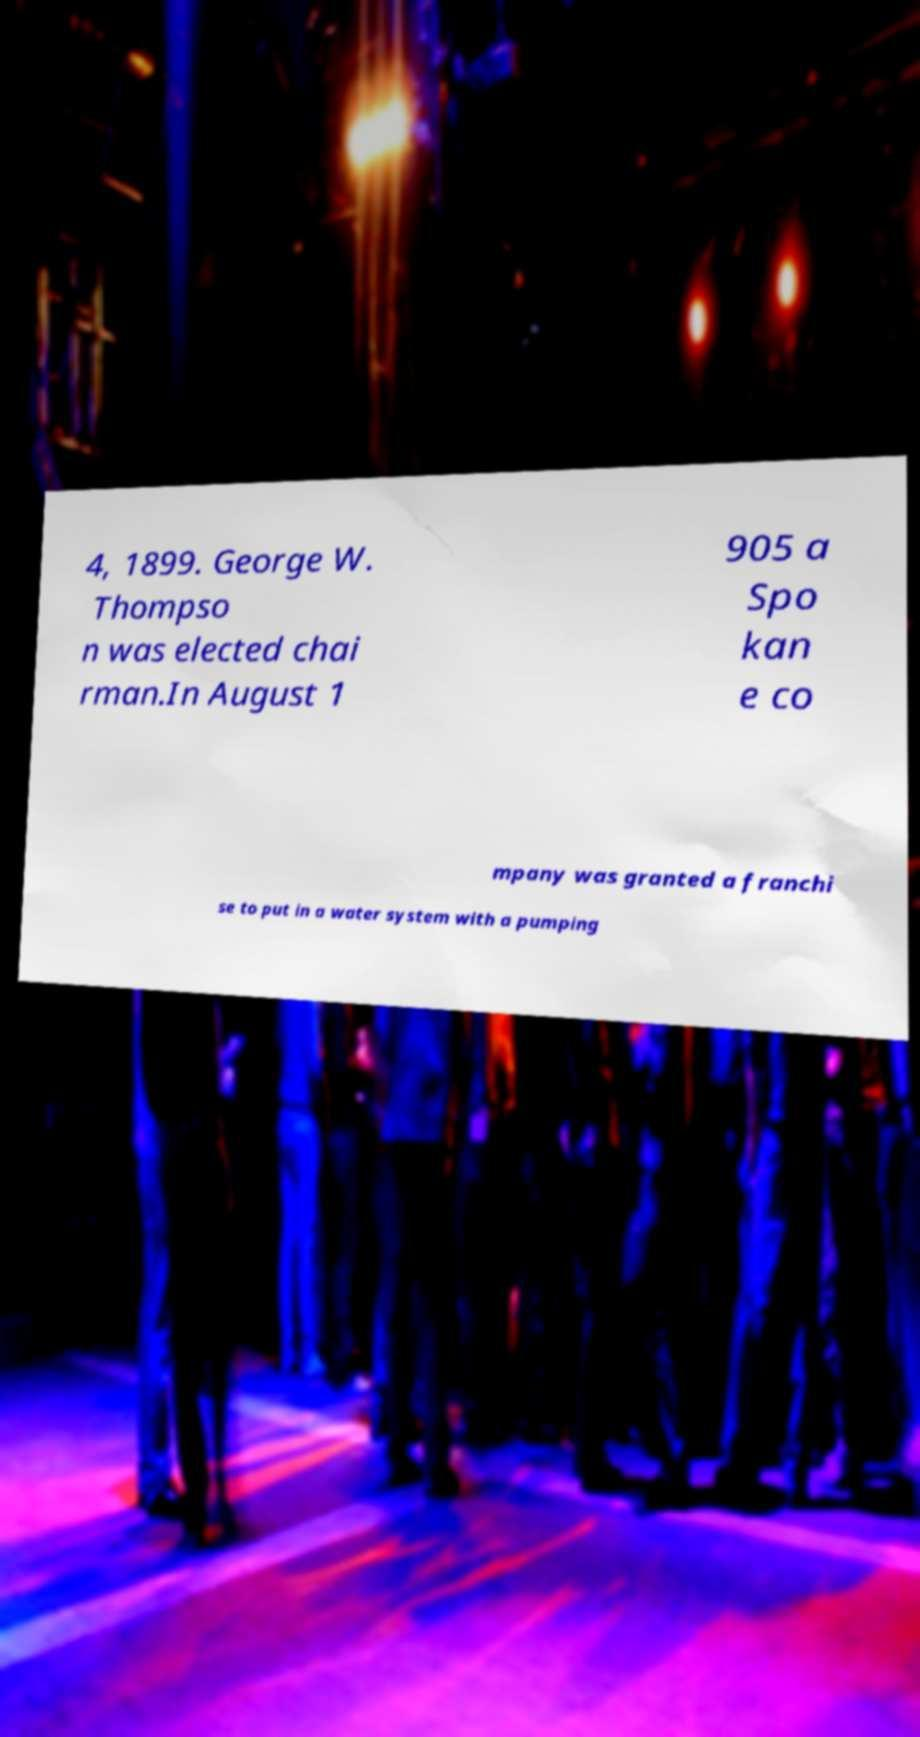What messages or text are displayed in this image? I need them in a readable, typed format. 4, 1899. George W. Thompso n was elected chai rman.In August 1 905 a Spo kan e co mpany was granted a franchi se to put in a water system with a pumping 